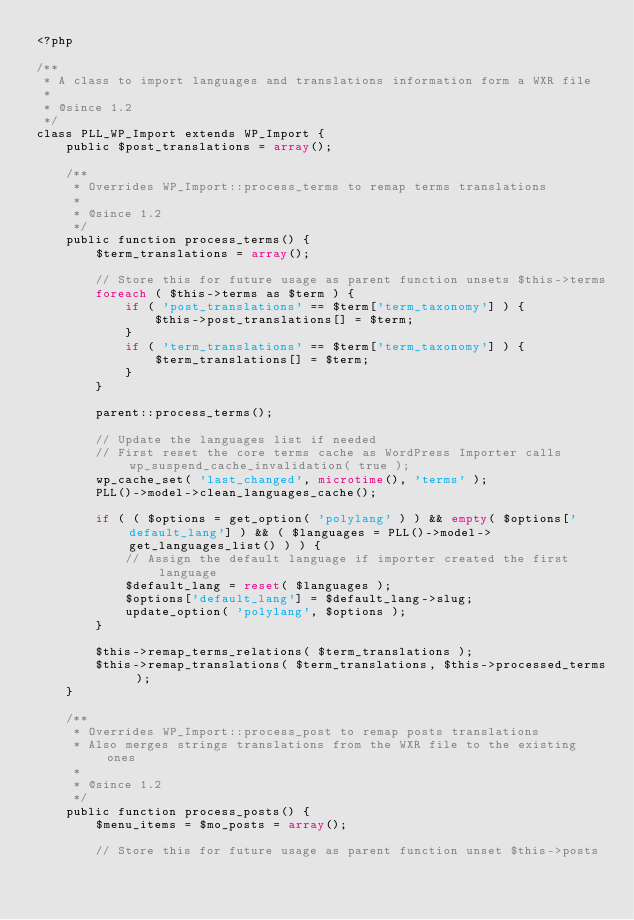<code> <loc_0><loc_0><loc_500><loc_500><_PHP_><?php

/**
 * A class to import languages and translations information form a WXR file
 *
 * @since 1.2
 */
class PLL_WP_Import extends WP_Import {
	public $post_translations = array();

	/**
	 * Overrides WP_Import::process_terms to remap terms translations
	 *
	 * @since 1.2
	 */
	public function process_terms() {
		$term_translations = array();

		// Store this for future usage as parent function unsets $this->terms
		foreach ( $this->terms as $term ) {
			if ( 'post_translations' == $term['term_taxonomy'] ) {
				$this->post_translations[] = $term;
			}
			if ( 'term_translations' == $term['term_taxonomy'] ) {
				$term_translations[] = $term;
			}
		}

		parent::process_terms();

		// Update the languages list if needed
		// First reset the core terms cache as WordPress Importer calls wp_suspend_cache_invalidation( true );
		wp_cache_set( 'last_changed', microtime(), 'terms' );
		PLL()->model->clean_languages_cache();

		if ( ( $options = get_option( 'polylang' ) ) && empty( $options['default_lang'] ) && ( $languages = PLL()->model->get_languages_list() ) ) {
			// Assign the default language if importer created the first language
			$default_lang = reset( $languages );
			$options['default_lang'] = $default_lang->slug;
			update_option( 'polylang', $options );
		}

		$this->remap_terms_relations( $term_translations );
		$this->remap_translations( $term_translations, $this->processed_terms );
	}

	/**
	 * Overrides WP_Import::process_post to remap posts translations
	 * Also merges strings translations from the WXR file to the existing ones
	 *
	 * @since 1.2
	 */
	public function process_posts() {
		$menu_items = $mo_posts = array();

		// Store this for future usage as parent function unset $this->posts</code> 